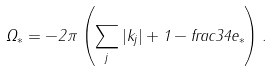<formula> <loc_0><loc_0><loc_500><loc_500>\Omega _ { * } = - 2 \pi \left ( \sum _ { j } | k _ { j } | + 1 - f r a c 3 4 e _ { * } \right ) .</formula> 